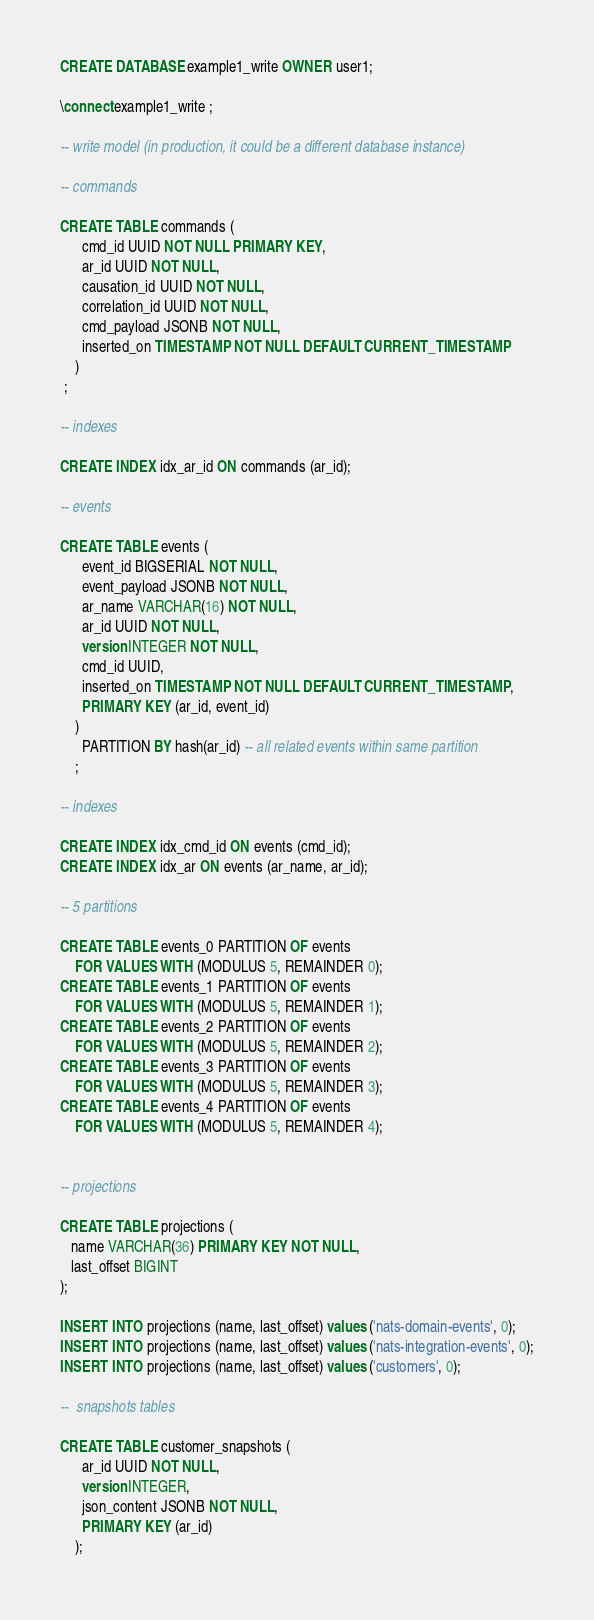Convert code to text. <code><loc_0><loc_0><loc_500><loc_500><_SQL_>CREATE DATABASE example1_write OWNER user1;

\connect example1_write ;

-- write model (in production, it could be a different database instance)

-- commands

CREATE TABLE commands (
      cmd_id UUID NOT NULL PRIMARY KEY,
      ar_id UUID NOT NULL,
      causation_id UUID NOT NULL,
      correlation_id UUID NOT NULL,
      cmd_payload JSONB NOT NULL,
      inserted_on TIMESTAMP NOT NULL DEFAULT CURRENT_TIMESTAMP
    )
 ;

-- indexes

CREATE INDEX idx_ar_id ON commands (ar_id);

-- events

CREATE TABLE events (
      event_id BIGSERIAL NOT NULL,
      event_payload JSONB NOT NULL,
      ar_name VARCHAR(16) NOT NULL,
      ar_id UUID NOT NULL,
      version INTEGER NOT NULL,
      cmd_id UUID,
      inserted_on TIMESTAMP NOT NULL DEFAULT CURRENT_TIMESTAMP,
      PRIMARY KEY (ar_id, event_id)
    )
      PARTITION BY hash(ar_id) -- all related events within same partition
    ;

-- indexes

CREATE INDEX idx_cmd_id ON events (cmd_id);
CREATE INDEX idx_ar ON events (ar_name, ar_id);

-- 5 partitions

CREATE TABLE events_0 PARTITION OF events
    FOR VALUES WITH (MODULUS 5, REMAINDER 0);
CREATE TABLE events_1 PARTITION OF events
    FOR VALUES WITH (MODULUS 5, REMAINDER 1);
CREATE TABLE events_2 PARTITION OF events
    FOR VALUES WITH (MODULUS 5, REMAINDER 2);
CREATE TABLE events_3 PARTITION OF events
    FOR VALUES WITH (MODULUS 5, REMAINDER 3);
CREATE TABLE events_4 PARTITION OF events
    FOR VALUES WITH (MODULUS 5, REMAINDER 4);


-- projections

CREATE TABLE projections (
   name VARCHAR(36) PRIMARY KEY NOT NULL,
   last_offset BIGINT
);

INSERT INTO projections (name, last_offset) values ('nats-domain-events', 0);
INSERT INTO projections (name, last_offset) values ('nats-integration-events', 0);
INSERT INTO projections (name, last_offset) values ('customers', 0);

--  snapshots tables

CREATE TABLE customer_snapshots (
      ar_id UUID NOT NULL,
      version INTEGER,
      json_content JSONB NOT NULL,
      PRIMARY KEY (ar_id)
    );
</code> 